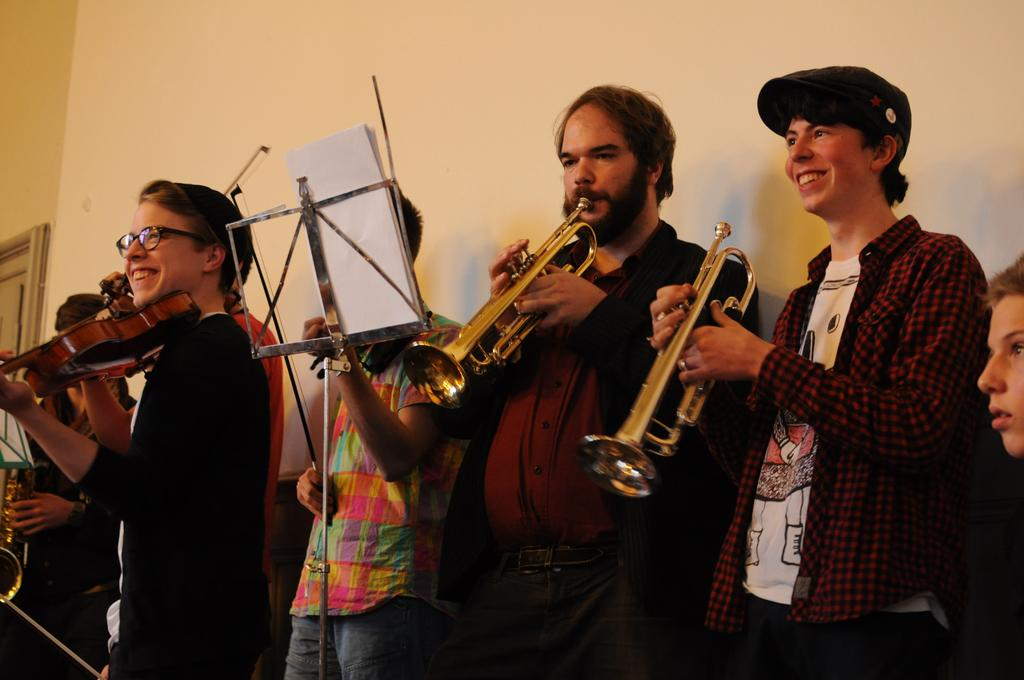What are the people in the image doing? The people in the image are playing musical instruments. What else can be seen in the image besides the people? There are papers on a stand in the image. What is the value of the harbor in the image? There is no harbor present in the image, so it is not possible to determine its value. 